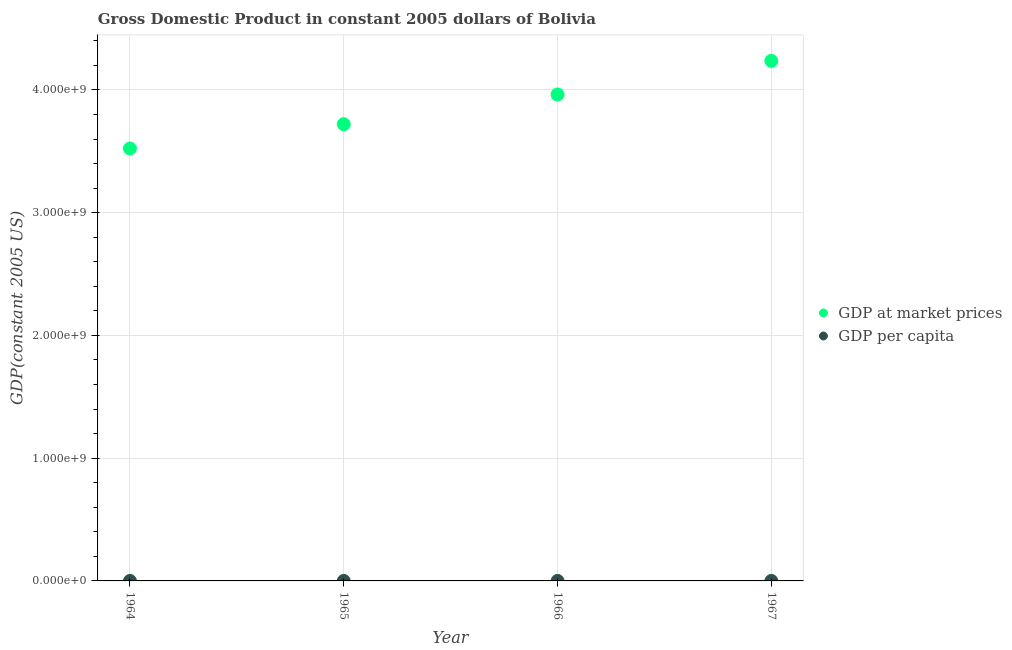What is the gdp at market prices in 1964?
Provide a short and direct response. 3.52e+09. Across all years, what is the maximum gdp at market prices?
Your answer should be compact. 4.24e+09. Across all years, what is the minimum gdp per capita?
Your response must be concise. 882.83. In which year was the gdp per capita maximum?
Your answer should be compact. 1967. In which year was the gdp at market prices minimum?
Offer a terse response. 1964. What is the total gdp at market prices in the graph?
Offer a terse response. 1.54e+1. What is the difference between the gdp at market prices in 1964 and that in 1966?
Give a very brief answer. -4.40e+08. What is the difference between the gdp at market prices in 1966 and the gdp per capita in 1967?
Your answer should be very brief. 3.96e+09. What is the average gdp at market prices per year?
Your answer should be very brief. 3.86e+09. In the year 1967, what is the difference between the gdp at market prices and gdp per capita?
Keep it short and to the point. 4.24e+09. What is the ratio of the gdp at market prices in 1964 to that in 1965?
Make the answer very short. 0.95. Is the gdp per capita in 1964 less than that in 1966?
Keep it short and to the point. Yes. What is the difference between the highest and the second highest gdp at market prices?
Provide a short and direct response. 2.74e+08. What is the difference between the highest and the lowest gdp per capita?
Your answer should be very brief. 117.15. In how many years, is the gdp per capita greater than the average gdp per capita taken over all years?
Keep it short and to the point. 2. Is the sum of the gdp per capita in 1965 and 1966 greater than the maximum gdp at market prices across all years?
Your response must be concise. No. Does the gdp per capita monotonically increase over the years?
Your answer should be very brief. Yes. Is the gdp per capita strictly less than the gdp at market prices over the years?
Your response must be concise. Yes. How many dotlines are there?
Offer a terse response. 2. Are the values on the major ticks of Y-axis written in scientific E-notation?
Your answer should be very brief. Yes. Does the graph contain any zero values?
Give a very brief answer. No. Does the graph contain grids?
Make the answer very short. Yes. Where does the legend appear in the graph?
Keep it short and to the point. Center right. How are the legend labels stacked?
Provide a short and direct response. Vertical. What is the title of the graph?
Offer a very short reply. Gross Domestic Product in constant 2005 dollars of Bolivia. Does "Investments" appear as one of the legend labels in the graph?
Provide a short and direct response. No. What is the label or title of the Y-axis?
Provide a short and direct response. GDP(constant 2005 US). What is the GDP(constant 2005 US) of GDP at market prices in 1964?
Keep it short and to the point. 3.52e+09. What is the GDP(constant 2005 US) of GDP per capita in 1964?
Provide a short and direct response. 882.83. What is the GDP(constant 2005 US) of GDP at market prices in 1965?
Your answer should be compact. 3.72e+09. What is the GDP(constant 2005 US) in GDP per capita in 1965?
Ensure brevity in your answer.  914.23. What is the GDP(constant 2005 US) in GDP at market prices in 1966?
Offer a terse response. 3.96e+09. What is the GDP(constant 2005 US) in GDP per capita in 1966?
Make the answer very short. 954.38. What is the GDP(constant 2005 US) of GDP at market prices in 1967?
Offer a terse response. 4.24e+09. What is the GDP(constant 2005 US) of GDP per capita in 1967?
Provide a short and direct response. 999.98. Across all years, what is the maximum GDP(constant 2005 US) of GDP at market prices?
Your answer should be compact. 4.24e+09. Across all years, what is the maximum GDP(constant 2005 US) in GDP per capita?
Offer a very short reply. 999.98. Across all years, what is the minimum GDP(constant 2005 US) in GDP at market prices?
Give a very brief answer. 3.52e+09. Across all years, what is the minimum GDP(constant 2005 US) in GDP per capita?
Your answer should be very brief. 882.83. What is the total GDP(constant 2005 US) in GDP at market prices in the graph?
Ensure brevity in your answer.  1.54e+1. What is the total GDP(constant 2005 US) of GDP per capita in the graph?
Give a very brief answer. 3751.43. What is the difference between the GDP(constant 2005 US) of GDP at market prices in 1964 and that in 1965?
Make the answer very short. -1.98e+08. What is the difference between the GDP(constant 2005 US) of GDP per capita in 1964 and that in 1965?
Your answer should be very brief. -31.39. What is the difference between the GDP(constant 2005 US) of GDP at market prices in 1964 and that in 1966?
Offer a very short reply. -4.40e+08. What is the difference between the GDP(constant 2005 US) in GDP per capita in 1964 and that in 1966?
Offer a terse response. -71.55. What is the difference between the GDP(constant 2005 US) in GDP at market prices in 1964 and that in 1967?
Your answer should be very brief. -7.14e+08. What is the difference between the GDP(constant 2005 US) of GDP per capita in 1964 and that in 1967?
Give a very brief answer. -117.15. What is the difference between the GDP(constant 2005 US) of GDP at market prices in 1965 and that in 1966?
Make the answer very short. -2.42e+08. What is the difference between the GDP(constant 2005 US) of GDP per capita in 1965 and that in 1966?
Your answer should be compact. -40.16. What is the difference between the GDP(constant 2005 US) in GDP at market prices in 1965 and that in 1967?
Provide a short and direct response. -5.16e+08. What is the difference between the GDP(constant 2005 US) in GDP per capita in 1965 and that in 1967?
Keep it short and to the point. -85.76. What is the difference between the GDP(constant 2005 US) in GDP at market prices in 1966 and that in 1967?
Offer a terse response. -2.74e+08. What is the difference between the GDP(constant 2005 US) of GDP per capita in 1966 and that in 1967?
Offer a very short reply. -45.6. What is the difference between the GDP(constant 2005 US) of GDP at market prices in 1964 and the GDP(constant 2005 US) of GDP per capita in 1965?
Offer a terse response. 3.52e+09. What is the difference between the GDP(constant 2005 US) in GDP at market prices in 1964 and the GDP(constant 2005 US) in GDP per capita in 1966?
Your response must be concise. 3.52e+09. What is the difference between the GDP(constant 2005 US) in GDP at market prices in 1964 and the GDP(constant 2005 US) in GDP per capita in 1967?
Ensure brevity in your answer.  3.52e+09. What is the difference between the GDP(constant 2005 US) in GDP at market prices in 1965 and the GDP(constant 2005 US) in GDP per capita in 1966?
Ensure brevity in your answer.  3.72e+09. What is the difference between the GDP(constant 2005 US) in GDP at market prices in 1965 and the GDP(constant 2005 US) in GDP per capita in 1967?
Offer a terse response. 3.72e+09. What is the difference between the GDP(constant 2005 US) of GDP at market prices in 1966 and the GDP(constant 2005 US) of GDP per capita in 1967?
Make the answer very short. 3.96e+09. What is the average GDP(constant 2005 US) of GDP at market prices per year?
Keep it short and to the point. 3.86e+09. What is the average GDP(constant 2005 US) in GDP per capita per year?
Keep it short and to the point. 937.86. In the year 1964, what is the difference between the GDP(constant 2005 US) of GDP at market prices and GDP(constant 2005 US) of GDP per capita?
Ensure brevity in your answer.  3.52e+09. In the year 1965, what is the difference between the GDP(constant 2005 US) in GDP at market prices and GDP(constant 2005 US) in GDP per capita?
Offer a very short reply. 3.72e+09. In the year 1966, what is the difference between the GDP(constant 2005 US) in GDP at market prices and GDP(constant 2005 US) in GDP per capita?
Your answer should be very brief. 3.96e+09. In the year 1967, what is the difference between the GDP(constant 2005 US) in GDP at market prices and GDP(constant 2005 US) in GDP per capita?
Offer a terse response. 4.24e+09. What is the ratio of the GDP(constant 2005 US) in GDP at market prices in 1964 to that in 1965?
Your response must be concise. 0.95. What is the ratio of the GDP(constant 2005 US) in GDP per capita in 1964 to that in 1965?
Give a very brief answer. 0.97. What is the ratio of the GDP(constant 2005 US) in GDP at market prices in 1964 to that in 1966?
Provide a succinct answer. 0.89. What is the ratio of the GDP(constant 2005 US) in GDP per capita in 1964 to that in 1966?
Make the answer very short. 0.93. What is the ratio of the GDP(constant 2005 US) of GDP at market prices in 1964 to that in 1967?
Your answer should be compact. 0.83. What is the ratio of the GDP(constant 2005 US) in GDP per capita in 1964 to that in 1967?
Your answer should be very brief. 0.88. What is the ratio of the GDP(constant 2005 US) of GDP at market prices in 1965 to that in 1966?
Make the answer very short. 0.94. What is the ratio of the GDP(constant 2005 US) of GDP per capita in 1965 to that in 1966?
Your answer should be compact. 0.96. What is the ratio of the GDP(constant 2005 US) of GDP at market prices in 1965 to that in 1967?
Give a very brief answer. 0.88. What is the ratio of the GDP(constant 2005 US) in GDP per capita in 1965 to that in 1967?
Provide a succinct answer. 0.91. What is the ratio of the GDP(constant 2005 US) in GDP at market prices in 1966 to that in 1967?
Offer a very short reply. 0.94. What is the ratio of the GDP(constant 2005 US) of GDP per capita in 1966 to that in 1967?
Your answer should be compact. 0.95. What is the difference between the highest and the second highest GDP(constant 2005 US) in GDP at market prices?
Your answer should be compact. 2.74e+08. What is the difference between the highest and the second highest GDP(constant 2005 US) in GDP per capita?
Your response must be concise. 45.6. What is the difference between the highest and the lowest GDP(constant 2005 US) in GDP at market prices?
Make the answer very short. 7.14e+08. What is the difference between the highest and the lowest GDP(constant 2005 US) in GDP per capita?
Keep it short and to the point. 117.15. 